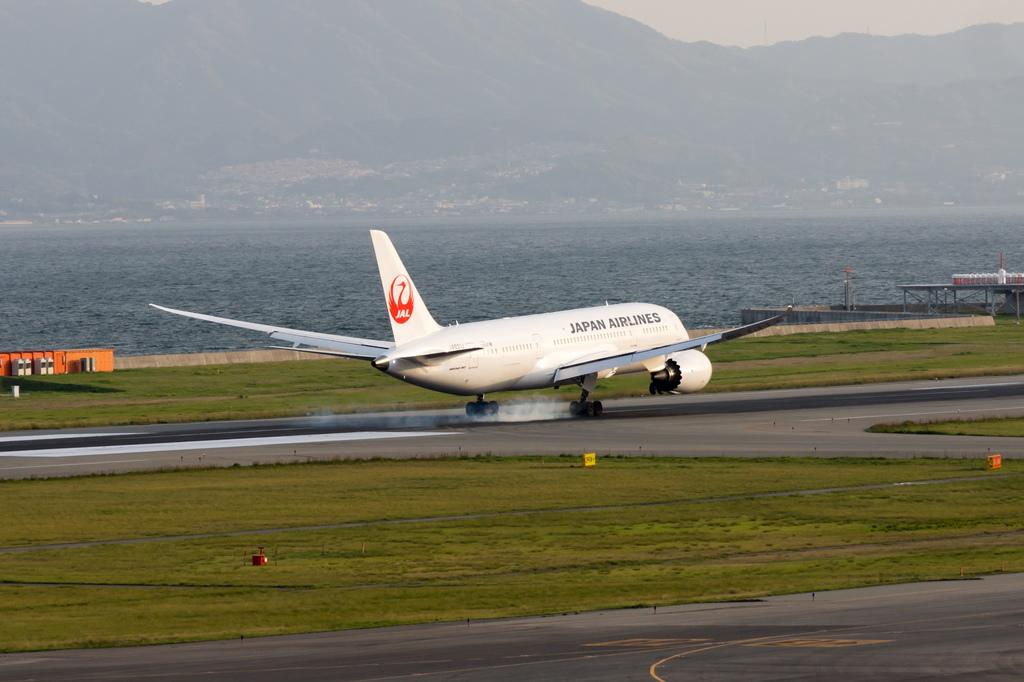Provide a one-sentence caption for the provided image. An airplane from Japan Airlines lands on the runway. 